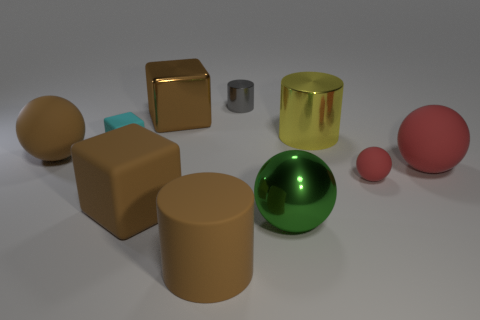Subtract all brown spheres. How many spheres are left? 3 Subtract all brown cubes. How many cubes are left? 1 Subtract 1 spheres. How many spheres are left? 3 Subtract all purple balls. Subtract all red cylinders. How many balls are left? 4 Subtract all cylinders. How many objects are left? 7 Add 9 tiny brown cubes. How many tiny brown cubes exist? 9 Subtract 0 red blocks. How many objects are left? 10 Subtract all big brown rubber blocks. Subtract all cyan cubes. How many objects are left? 8 Add 5 big brown matte cubes. How many big brown matte cubes are left? 6 